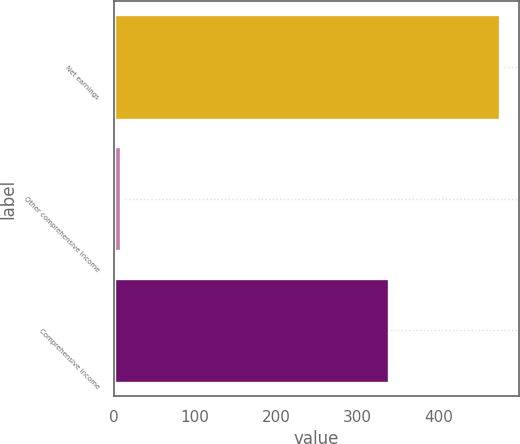Convert chart. <chart><loc_0><loc_0><loc_500><loc_500><bar_chart><fcel>Net earnings<fcel>Other comprehensive income<fcel>Comprehensive income<nl><fcel>475.2<fcel>8.7<fcel>339.1<nl></chart> 